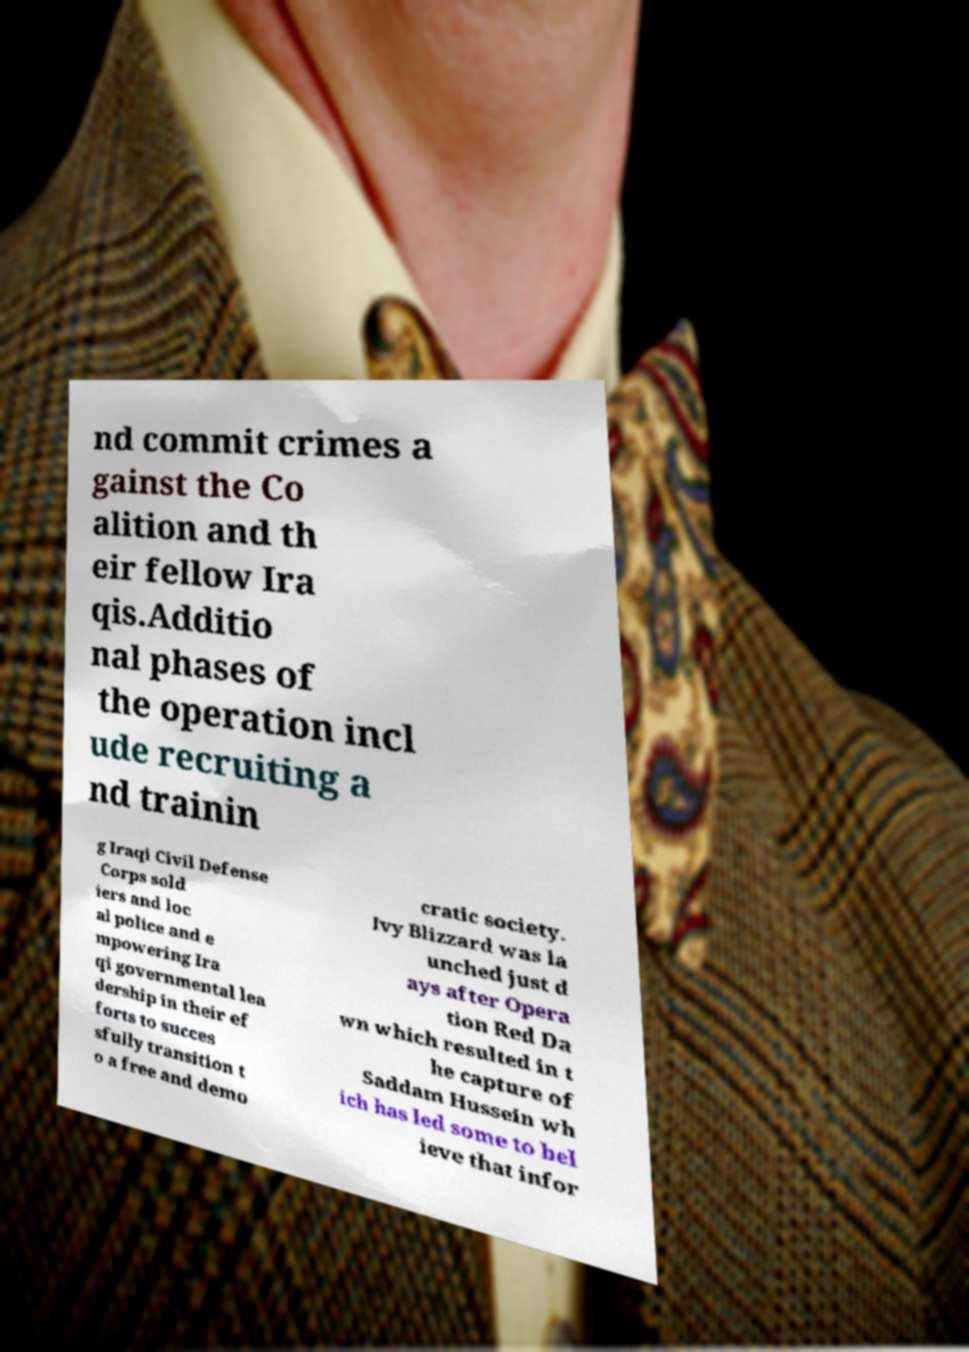Could you extract and type out the text from this image? nd commit crimes a gainst the Co alition and th eir fellow Ira qis.Additio nal phases of the operation incl ude recruiting a nd trainin g Iraqi Civil Defense Corps sold iers and loc al police and e mpowering Ira qi governmental lea dership in their ef forts to succes sfully transition t o a free and demo cratic society. Ivy Blizzard was la unched just d ays after Opera tion Red Da wn which resulted in t he capture of Saddam Hussein wh ich has led some to bel ieve that infor 